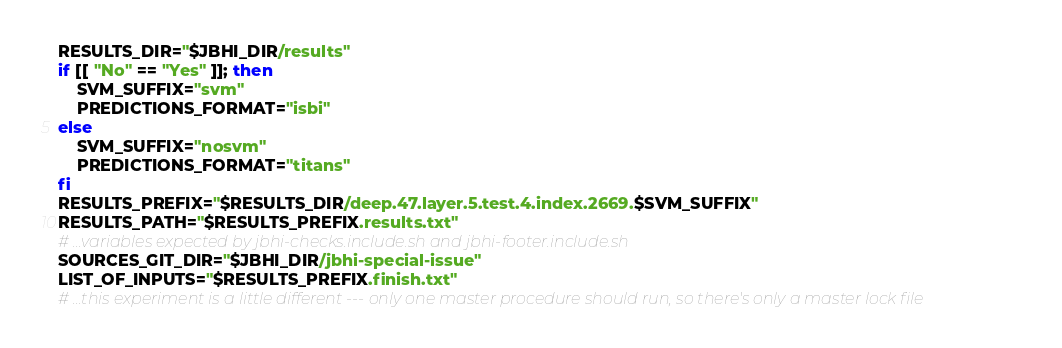<code> <loc_0><loc_0><loc_500><loc_500><_Bash_>RESULTS_DIR="$JBHI_DIR/results"
if [[ "No" == "Yes" ]]; then
    SVM_SUFFIX="svm"
    PREDICTIONS_FORMAT="isbi"
else
    SVM_SUFFIX="nosvm"
    PREDICTIONS_FORMAT="titans"
fi
RESULTS_PREFIX="$RESULTS_DIR/deep.47.layer.5.test.4.index.2669.$SVM_SUFFIX"
RESULTS_PATH="$RESULTS_PREFIX.results.txt"
# ...variables expected by jbhi-checks.include.sh and jbhi-footer.include.sh
SOURCES_GIT_DIR="$JBHI_DIR/jbhi-special-issue"
LIST_OF_INPUTS="$RESULTS_PREFIX.finish.txt"
# ...this experiment is a little different --- only one master procedure should run, so there's only a master lock file</code> 